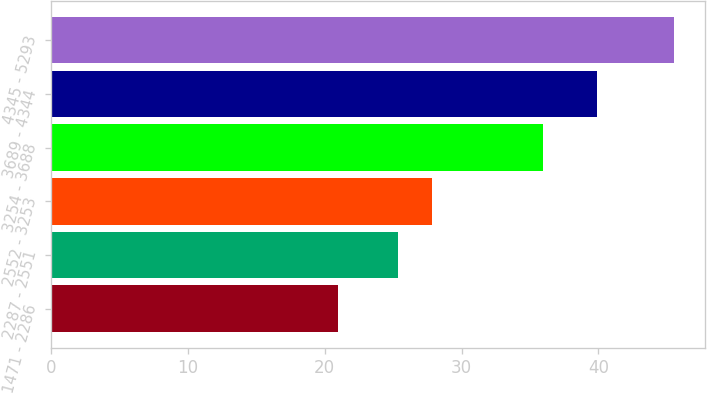Convert chart to OTSL. <chart><loc_0><loc_0><loc_500><loc_500><bar_chart><fcel>1471 - 2286<fcel>2287 - 2551<fcel>2552 - 3253<fcel>3254 - 3688<fcel>3689 - 4344<fcel>4345 - 5293<nl><fcel>20.95<fcel>25.37<fcel>27.83<fcel>35.96<fcel>39.92<fcel>45.52<nl></chart> 